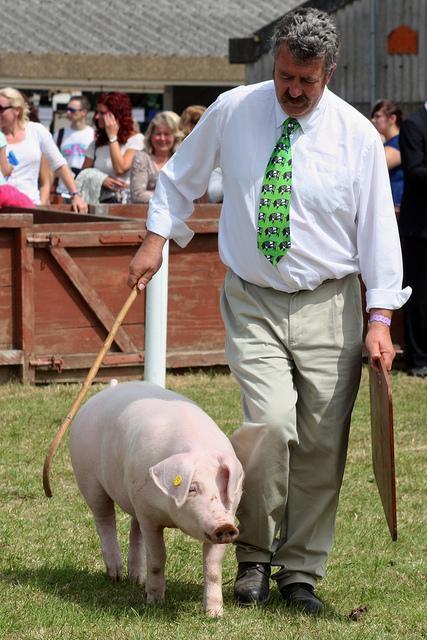How many people are in the picture?
Give a very brief answer. 6. 